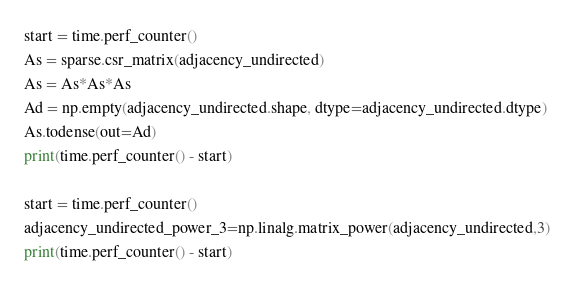Convert code to text. <code><loc_0><loc_0><loc_500><loc_500><_Python_>start = time.perf_counter()
As = sparse.csr_matrix(adjacency_undirected)
As = As*As*As
Ad = np.empty(adjacency_undirected.shape, dtype=adjacency_undirected.dtype)
As.todense(out=Ad)
print(time.perf_counter() - start)

start = time.perf_counter()
adjacency_undirected_power_3=np.linalg.matrix_power(adjacency_undirected,3)
print(time.perf_counter() - start)</code> 